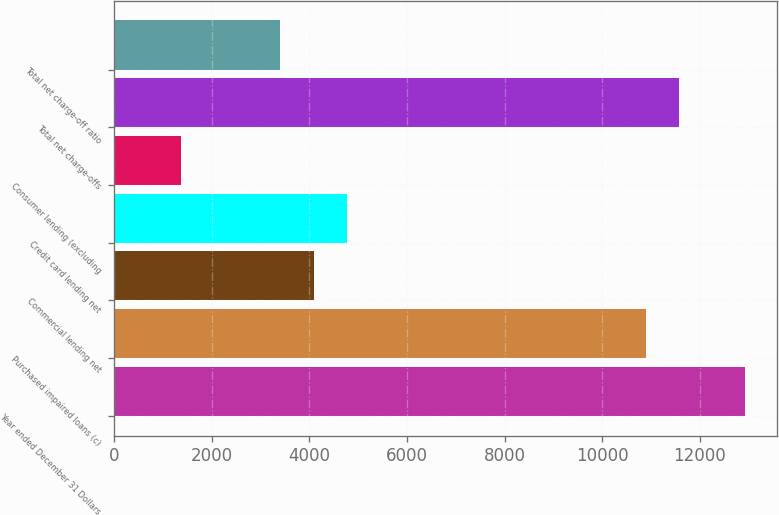<chart> <loc_0><loc_0><loc_500><loc_500><bar_chart><fcel>Year ended December 31 Dollars<fcel>Purchased impaired loans (c)<fcel>Commercial lending net<fcel>Credit card lending net<fcel>Consumer lending (excluding<fcel>Total net charge-offs<fcel>Total net charge-off ratio<nl><fcel>12931<fcel>10889.3<fcel>4083.74<fcel>4764.3<fcel>1361.5<fcel>11569.9<fcel>3403.18<nl></chart> 